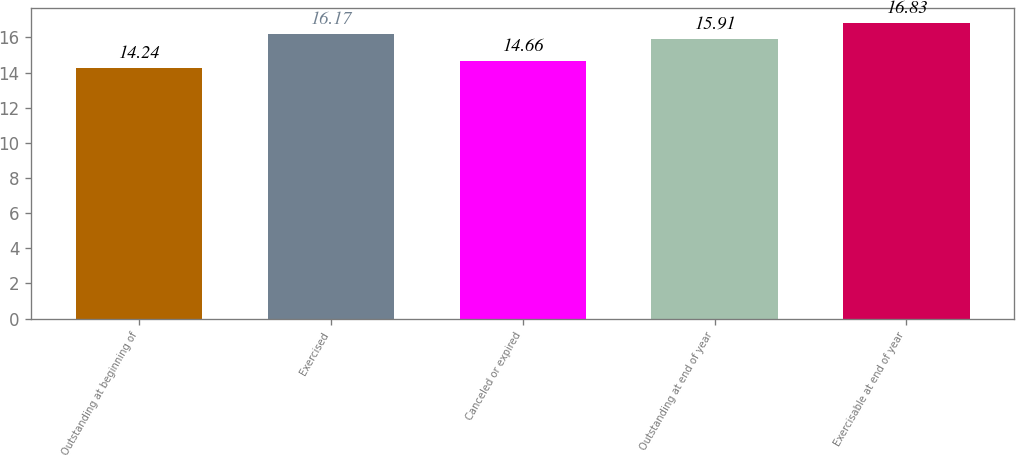Convert chart to OTSL. <chart><loc_0><loc_0><loc_500><loc_500><bar_chart><fcel>Outstanding at beginning of<fcel>Exercised<fcel>Canceled or expired<fcel>Outstanding at end of year<fcel>Exercisable at end of year<nl><fcel>14.24<fcel>16.17<fcel>14.66<fcel>15.91<fcel>16.83<nl></chart> 